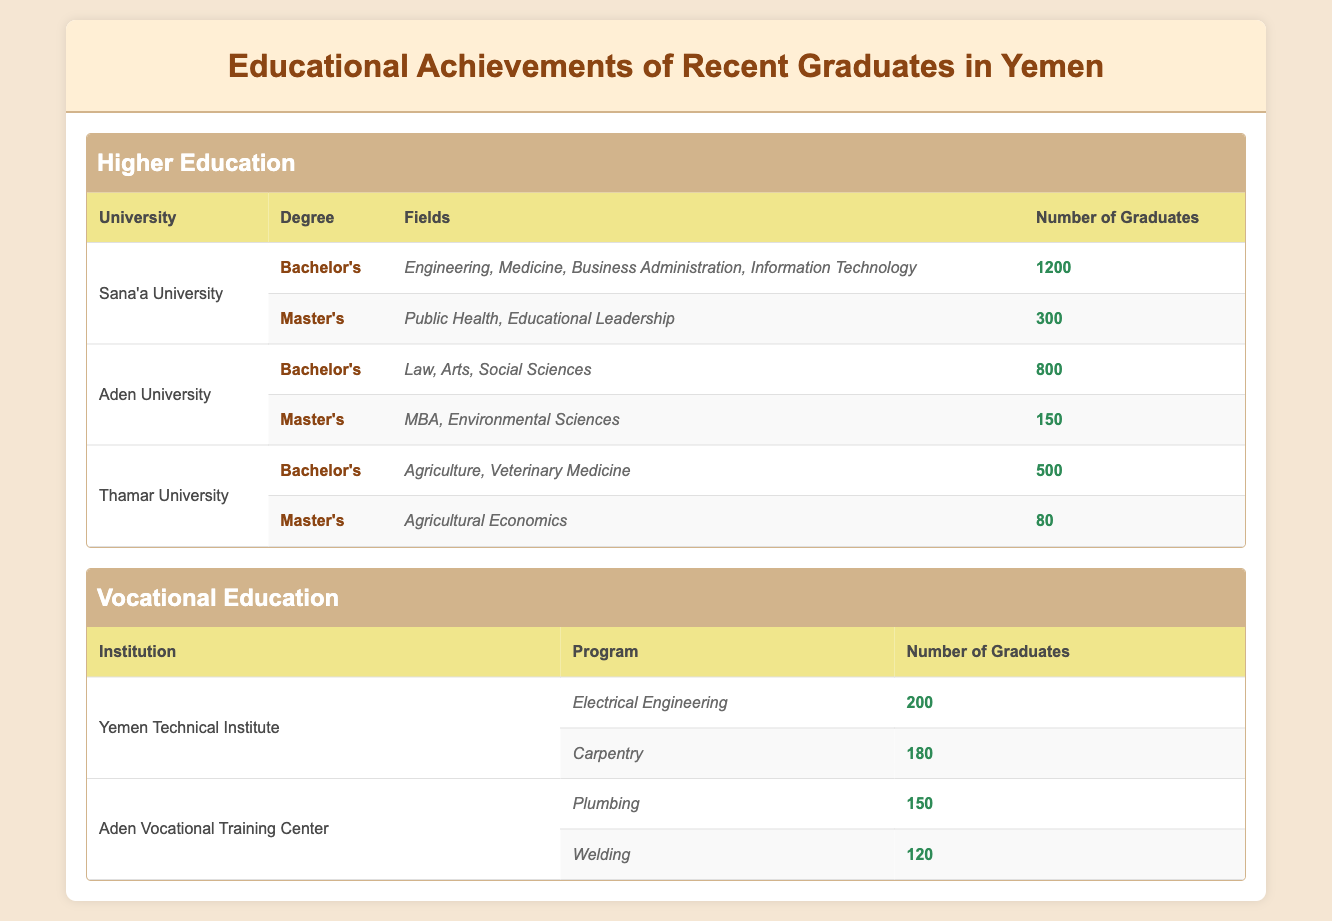What is the total number of graduates from Sana'a University? From the table, Sana'a University has 1200 graduates with Bachelor's degrees and 300 graduates with Master's degrees. Adding these together gives us 1200 + 300 = 1500 graduates.
Answer: 1500 Which university offers a Master's degree in Agricultural Economics? According to the table, Thamar University is the only university listed that offers a Master's degree in Agricultural Economics.
Answer: Thamar University How many graduates did Aden University have for Bachelor’s degrees? The table shows that Aden University had 800 graduates for Bachelor's degrees. This is directly stated in the 'Number of Graduates' column for Aden University under the Bachelor's degree row.
Answer: 800 What is the total number of graduates across all vocational education programs? The table lists two vocational institutions: Yemen Technical Institute with 200 (Electrical Engineering) + 180 (Carpentry) = 380, and Aden Vocational Training Center with 150 (Plumbing) + 120 (Welding) = 270. Adding these totals gives us 380 + 270 = 650 graduates from all vocational programs.
Answer: 650 Does Sana'a University offer degrees in Medicine? The table lists the fields under the Bachelor's degree for Sana'a University and includes 'Medicine' among them. Thus, Sana'a University does offer degrees in Medicine.
Answer: Yes What is the difference in the number of graduates between Aden University’s Bachelor’s and Master’s programs? Aden University has 800 graduates for Bachelor's degrees and 150 for Master's degrees. The difference is calculated by subtracting the number of Master's graduates from the Bachelor's graduates: 800 - 150 = 650.
Answer: 650 Which university has the highest number of graduates and what is that number? You compare the total number of graduates from each university. Sana'a University has 1500 graduates, Aden University has 950 (800 + 150), and Thamar University has 580 (500 + 80). The highest number is from Sana'a University with 1500 graduates.
Answer: 1500 What percentage of graduates from Yemen Technical Institute are from the Electrical Engineering program? Yemen Technical Institute has a total of 380 graduates (200 in Electrical Engineering and 180 in Carpentry). The percentage for Electrical Engineering is calculated as (200/380) * 100 = 52.63%.
Answer: 52.63% Are there more graduates in vocational education than higher education overall? The total number of graduates in higher education is 3050 (1500 from Sana'a University, 950 from Aden University, and 580 from Thamar University). In vocational education, there are 650 graduates. Comparing them shows that higher education has more graduates than vocational education.
Answer: No 